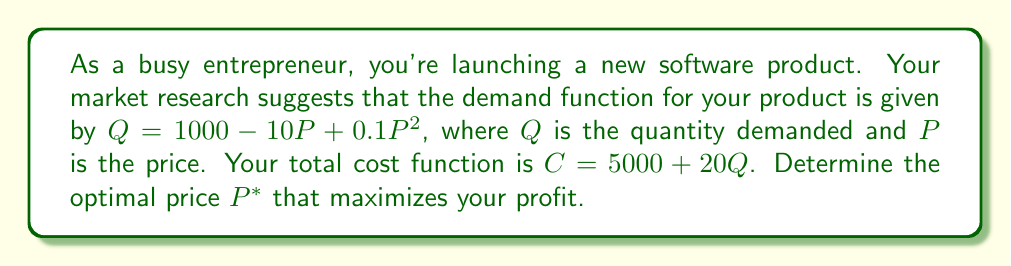Provide a solution to this math problem. Let's approach this step-by-step:

1) First, we need to define the profit function. Profit ($\Pi$) is revenue minus cost:

   $\Pi = PQ - C$

2) Substitute the given functions:

   $\Pi = P(1000 - 10P + 0.1P^2) - (5000 + 20(1000 - 10P + 0.1P^2))$

3) Expand this expression:

   $\Pi = 1000P - 10P^2 + 0.1P^3 - 5000 - 20000 + 200P - 2P^2$

4) Simplify:

   $\Pi = 0.1P^3 - 12P^2 + 1200P - 25000$

5) To find the maximum profit, we need to find where the derivative of $\Pi$ with respect to $P$ equals zero:

   $$\frac{d\Pi}{dP} = 0.3P^2 - 24P + 1200 = 0$$

6) This is a quadratic equation. We can solve it using the quadratic formula:

   $$P = \frac{-b \pm \sqrt{b^2 - 4ac}}{2a}$$

   Where $a = 0.3$, $b = -24$, and $c = 1200$

7) Solving this:

   $$P = \frac{24 \pm \sqrt{576 - 1440}}{0.6} = \frac{24 \pm \sqrt{-864}}{0.6}$$

8) Since we can't have a negative value under the square root, there's only one real solution:

   $$P^* = \frac{24}{0.6} = 40$$

9) To confirm this is a maximum (not a minimum), we can check the second derivative:

   $$\frac{d^2\Pi}{dP^2} = 0.6P - 24$$

   At $P = 40$, this equals 0.6(40) - 24 = 0, which is positive, confirming a maximum.
Answer: The optimal price $P^*$ that maximizes profit is $40. 